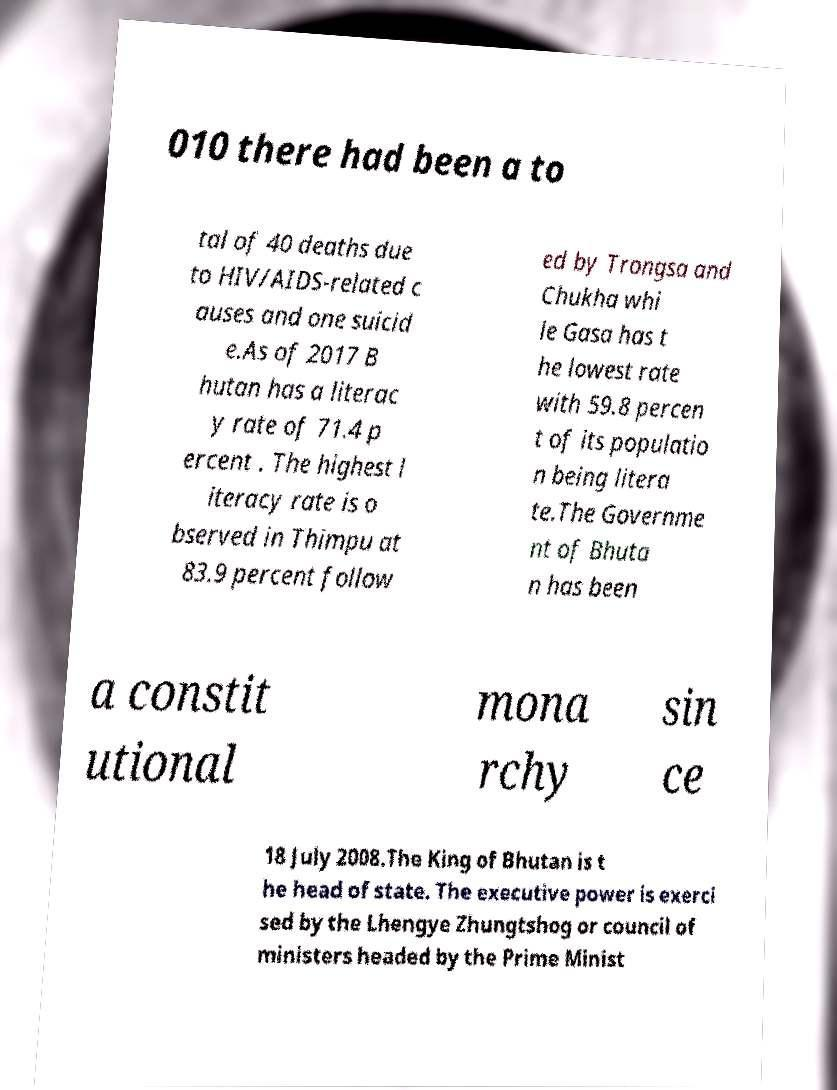Could you extract and type out the text from this image? 010 there had been a to tal of 40 deaths due to HIV/AIDS-related c auses and one suicid e.As of 2017 B hutan has a literac y rate of 71.4 p ercent . The highest l iteracy rate is o bserved in Thimpu at 83.9 percent follow ed by Trongsa and Chukha whi le Gasa has t he lowest rate with 59.8 percen t of its populatio n being litera te.The Governme nt of Bhuta n has been a constit utional mona rchy sin ce 18 July 2008.The King of Bhutan is t he head of state. The executive power is exerci sed by the Lhengye Zhungtshog or council of ministers headed by the Prime Minist 